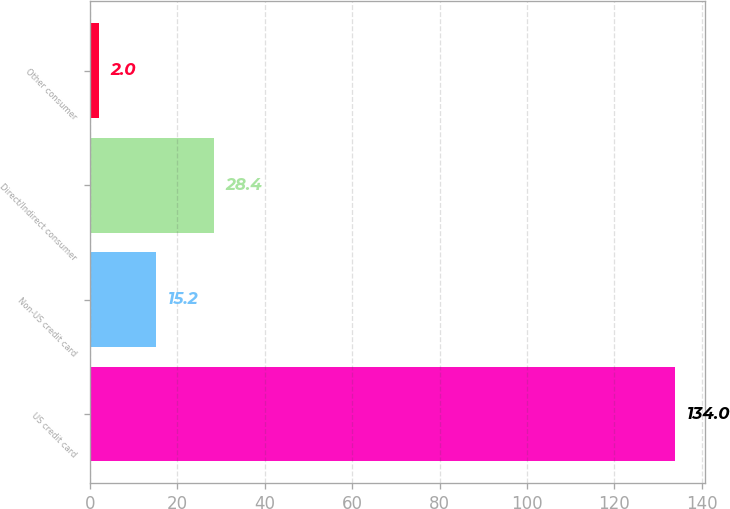<chart> <loc_0><loc_0><loc_500><loc_500><bar_chart><fcel>US credit card<fcel>Non-US credit card<fcel>Direct/Indirect consumer<fcel>Other consumer<nl><fcel>134<fcel>15.2<fcel>28.4<fcel>2<nl></chart> 